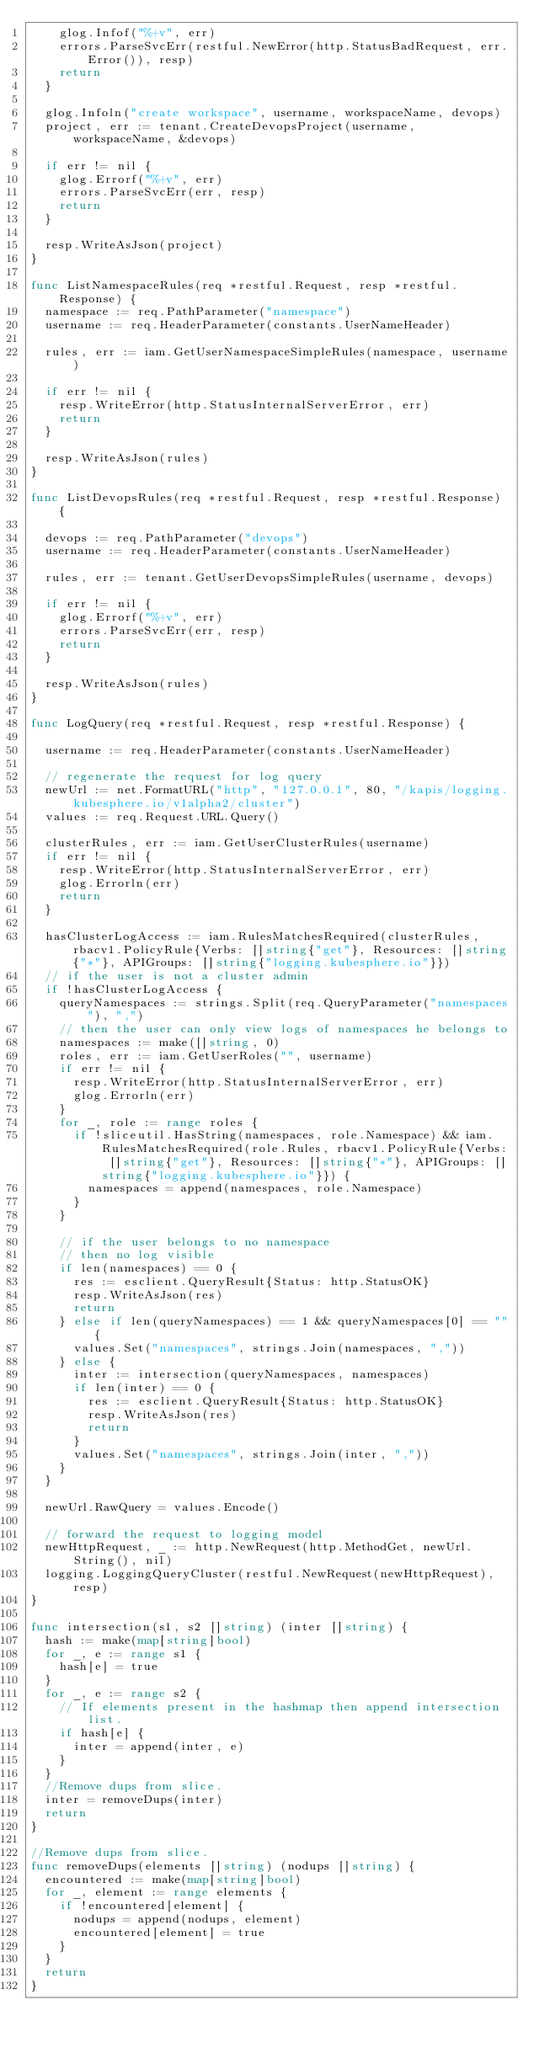Convert code to text. <code><loc_0><loc_0><loc_500><loc_500><_Go_>		glog.Infof("%+v", err)
		errors.ParseSvcErr(restful.NewError(http.StatusBadRequest, err.Error()), resp)
		return
	}

	glog.Infoln("create workspace", username, workspaceName, devops)
	project, err := tenant.CreateDevopsProject(username, workspaceName, &devops)

	if err != nil {
		glog.Errorf("%+v", err)
		errors.ParseSvcErr(err, resp)
		return
	}

	resp.WriteAsJson(project)
}

func ListNamespaceRules(req *restful.Request, resp *restful.Response) {
	namespace := req.PathParameter("namespace")
	username := req.HeaderParameter(constants.UserNameHeader)

	rules, err := iam.GetUserNamespaceSimpleRules(namespace, username)

	if err != nil {
		resp.WriteError(http.StatusInternalServerError, err)
		return
	}

	resp.WriteAsJson(rules)
}

func ListDevopsRules(req *restful.Request, resp *restful.Response) {

	devops := req.PathParameter("devops")
	username := req.HeaderParameter(constants.UserNameHeader)

	rules, err := tenant.GetUserDevopsSimpleRules(username, devops)

	if err != nil {
		glog.Errorf("%+v", err)
		errors.ParseSvcErr(err, resp)
		return
	}

	resp.WriteAsJson(rules)
}

func LogQuery(req *restful.Request, resp *restful.Response) {

	username := req.HeaderParameter(constants.UserNameHeader)

	// regenerate the request for log query
	newUrl := net.FormatURL("http", "127.0.0.1", 80, "/kapis/logging.kubesphere.io/v1alpha2/cluster")
	values := req.Request.URL.Query()

	clusterRules, err := iam.GetUserClusterRules(username)
	if err != nil {
		resp.WriteError(http.StatusInternalServerError, err)
		glog.Errorln(err)
		return
	}

	hasClusterLogAccess := iam.RulesMatchesRequired(clusterRules, rbacv1.PolicyRule{Verbs: []string{"get"}, Resources: []string{"*"}, APIGroups: []string{"logging.kubesphere.io"}})
	// if the user is not a cluster admin
	if !hasClusterLogAccess {
		queryNamespaces := strings.Split(req.QueryParameter("namespaces"), ",")
		// then the user can only view logs of namespaces he belongs to
		namespaces := make([]string, 0)
		roles, err := iam.GetUserRoles("", username)
		if err != nil {
			resp.WriteError(http.StatusInternalServerError, err)
			glog.Errorln(err)
		}
		for _, role := range roles {
			if !sliceutil.HasString(namespaces, role.Namespace) && iam.RulesMatchesRequired(role.Rules, rbacv1.PolicyRule{Verbs: []string{"get"}, Resources: []string{"*"}, APIGroups: []string{"logging.kubesphere.io"}}) {
				namespaces = append(namespaces, role.Namespace)
			}
		}

		// if the user belongs to no namespace
		// then no log visible
		if len(namespaces) == 0 {
			res := esclient.QueryResult{Status: http.StatusOK}
			resp.WriteAsJson(res)
			return
		} else if len(queryNamespaces) == 1 && queryNamespaces[0] == "" {
			values.Set("namespaces", strings.Join(namespaces, ","))
		} else {
			inter := intersection(queryNamespaces, namespaces)
			if len(inter) == 0 {
				res := esclient.QueryResult{Status: http.StatusOK}
				resp.WriteAsJson(res)
				return
			}
			values.Set("namespaces", strings.Join(inter, ","))
		}
	}

	newUrl.RawQuery = values.Encode()

	// forward the request to logging model
	newHttpRequest, _ := http.NewRequest(http.MethodGet, newUrl.String(), nil)
	logging.LoggingQueryCluster(restful.NewRequest(newHttpRequest), resp)
}

func intersection(s1, s2 []string) (inter []string) {
	hash := make(map[string]bool)
	for _, e := range s1 {
		hash[e] = true
	}
	for _, e := range s2 {
		// If elements present in the hashmap then append intersection list.
		if hash[e] {
			inter = append(inter, e)
		}
	}
	//Remove dups from slice.
	inter = removeDups(inter)
	return
}

//Remove dups from slice.
func removeDups(elements []string) (nodups []string) {
	encountered := make(map[string]bool)
	for _, element := range elements {
		if !encountered[element] {
			nodups = append(nodups, element)
			encountered[element] = true
		}
	}
	return
}
</code> 